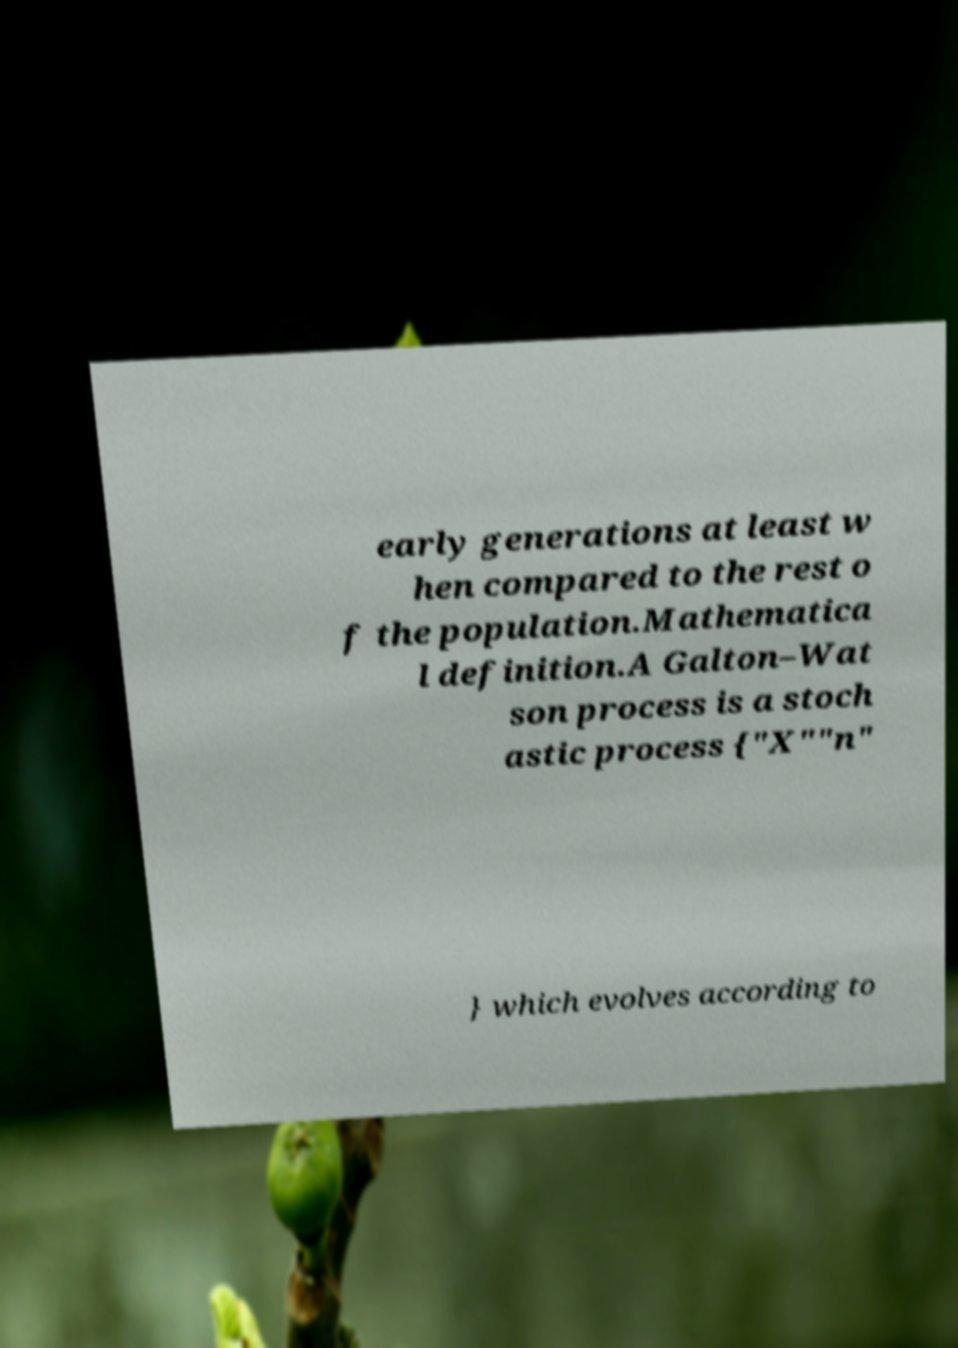What messages or text are displayed in this image? I need them in a readable, typed format. early generations at least w hen compared to the rest o f the population.Mathematica l definition.A Galton–Wat son process is a stoch astic process {"X""n" } which evolves according to 